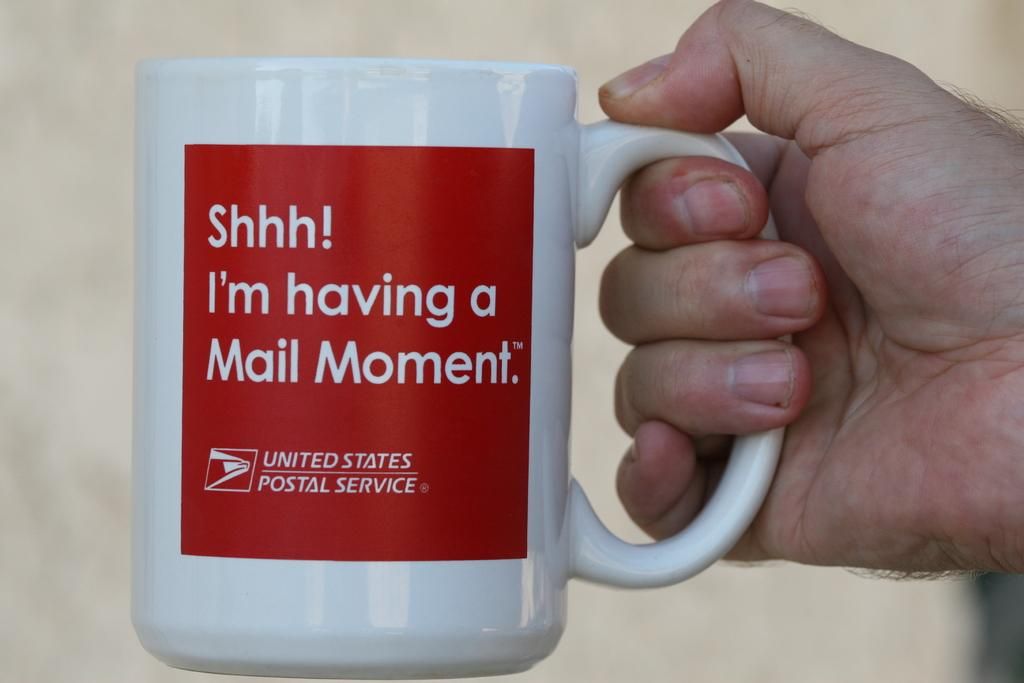<image>
Present a compact description of the photo's key features. A hand holding a coffee mug that says Shhhh! I'm having a Mail Moment on it. 